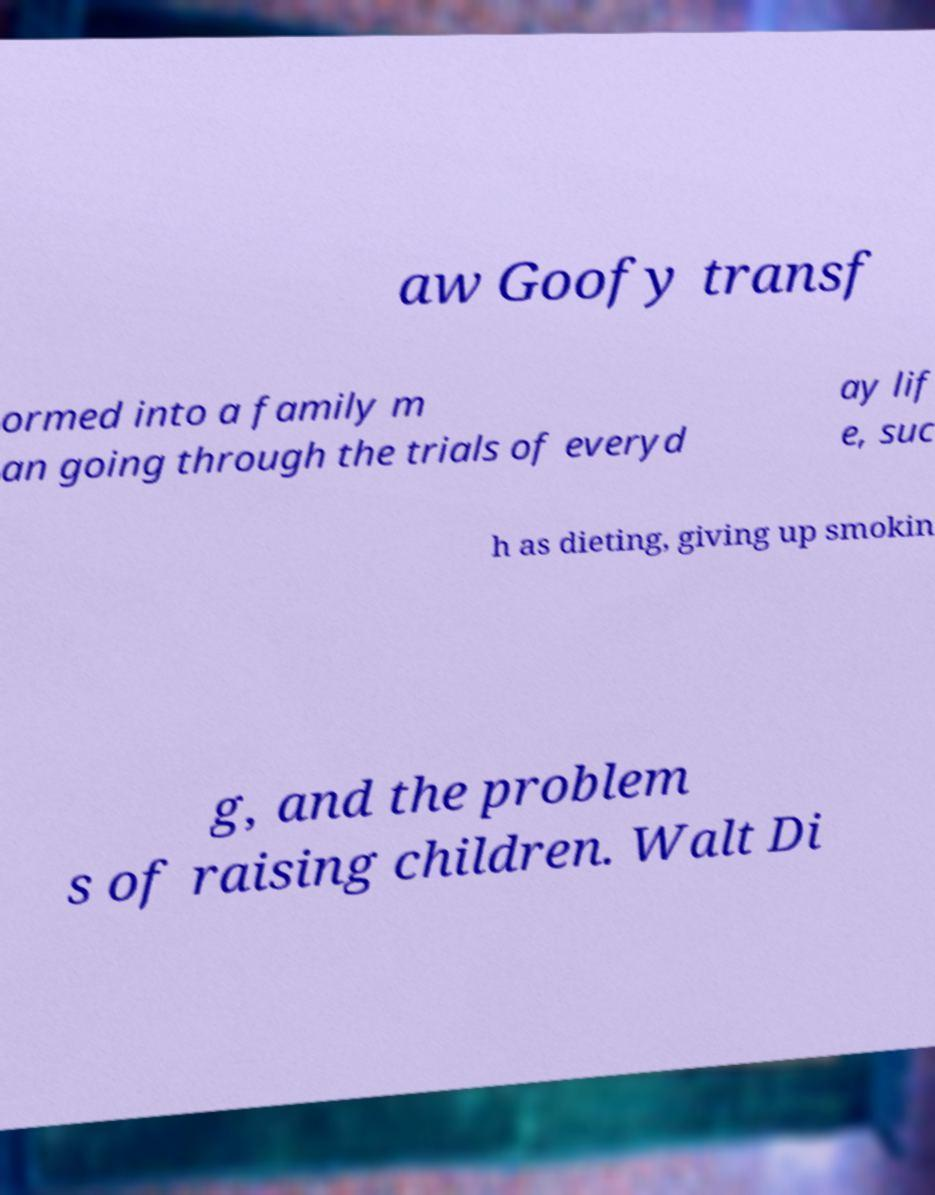Please read and relay the text visible in this image. What does it say? aw Goofy transf ormed into a family m an going through the trials of everyd ay lif e, suc h as dieting, giving up smokin g, and the problem s of raising children. Walt Di 